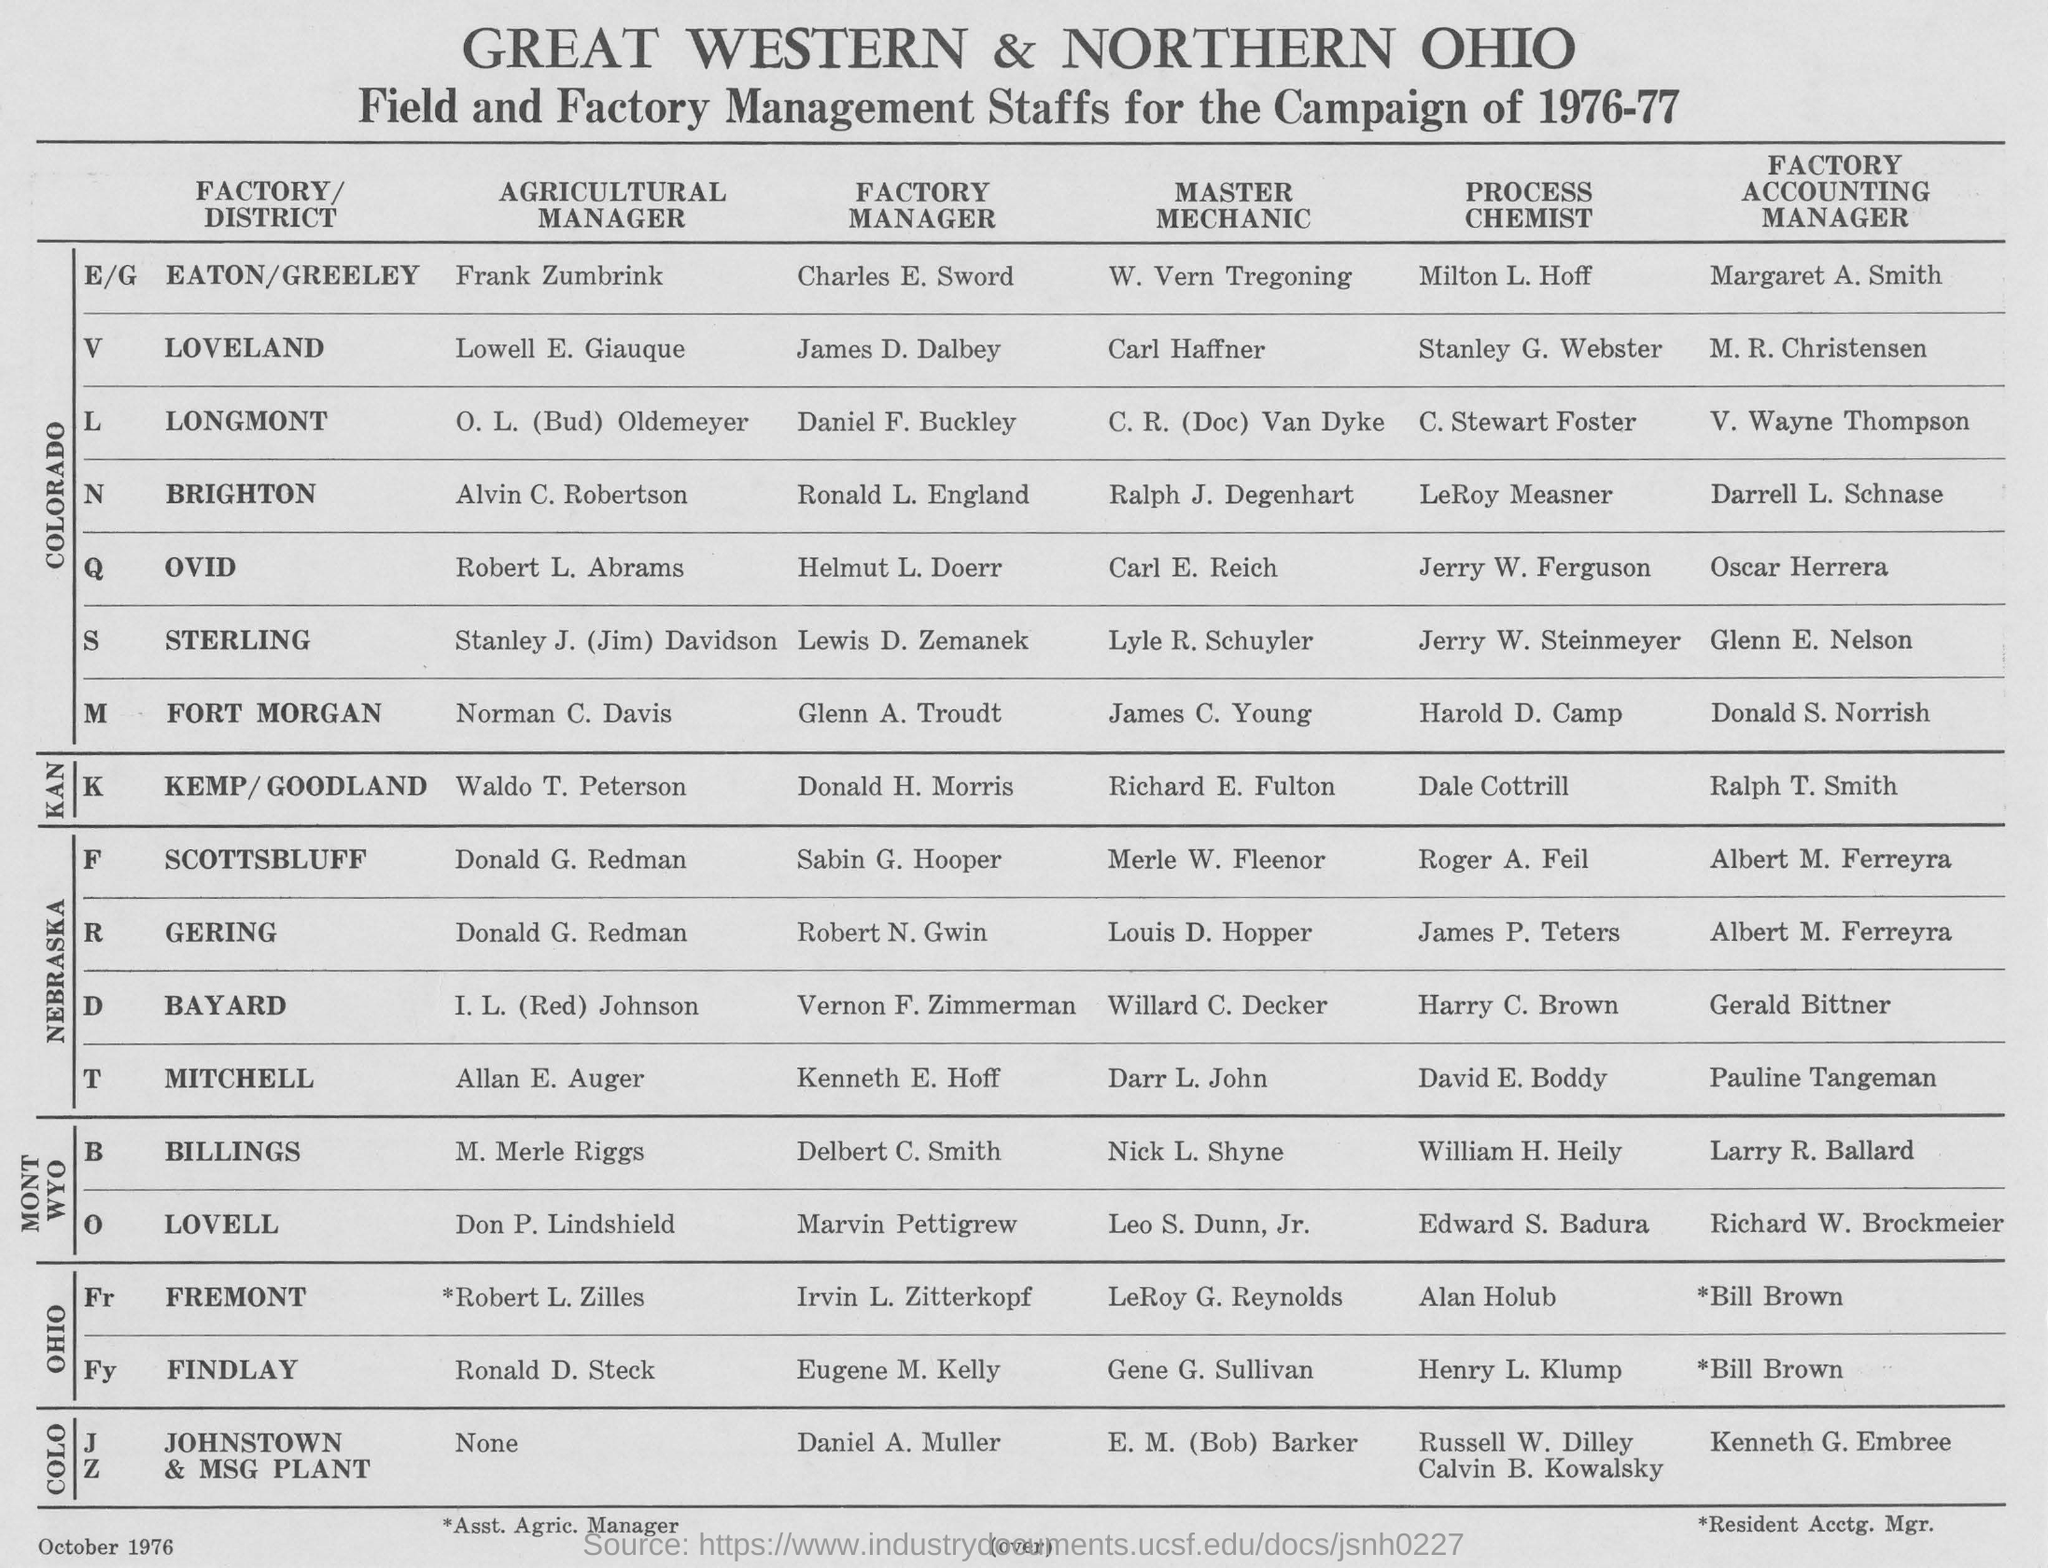Who is the Agricultural Manager of FINDLAY ?
Ensure brevity in your answer.  Ronald D. Steck. Who is the Factory Manager of LOVELL ?
Ensure brevity in your answer.  Marvin Pettigrew. Who is the Factory Accounting Manager of BAYARD ?
Offer a terse response. Gerald Bittner. Who is the Master Mechanic of OVID ?
Make the answer very short. CARL E. REICH. Who is the Process Chemist of GERING ?
Keep it short and to the point. JAMES P. TETERS. 